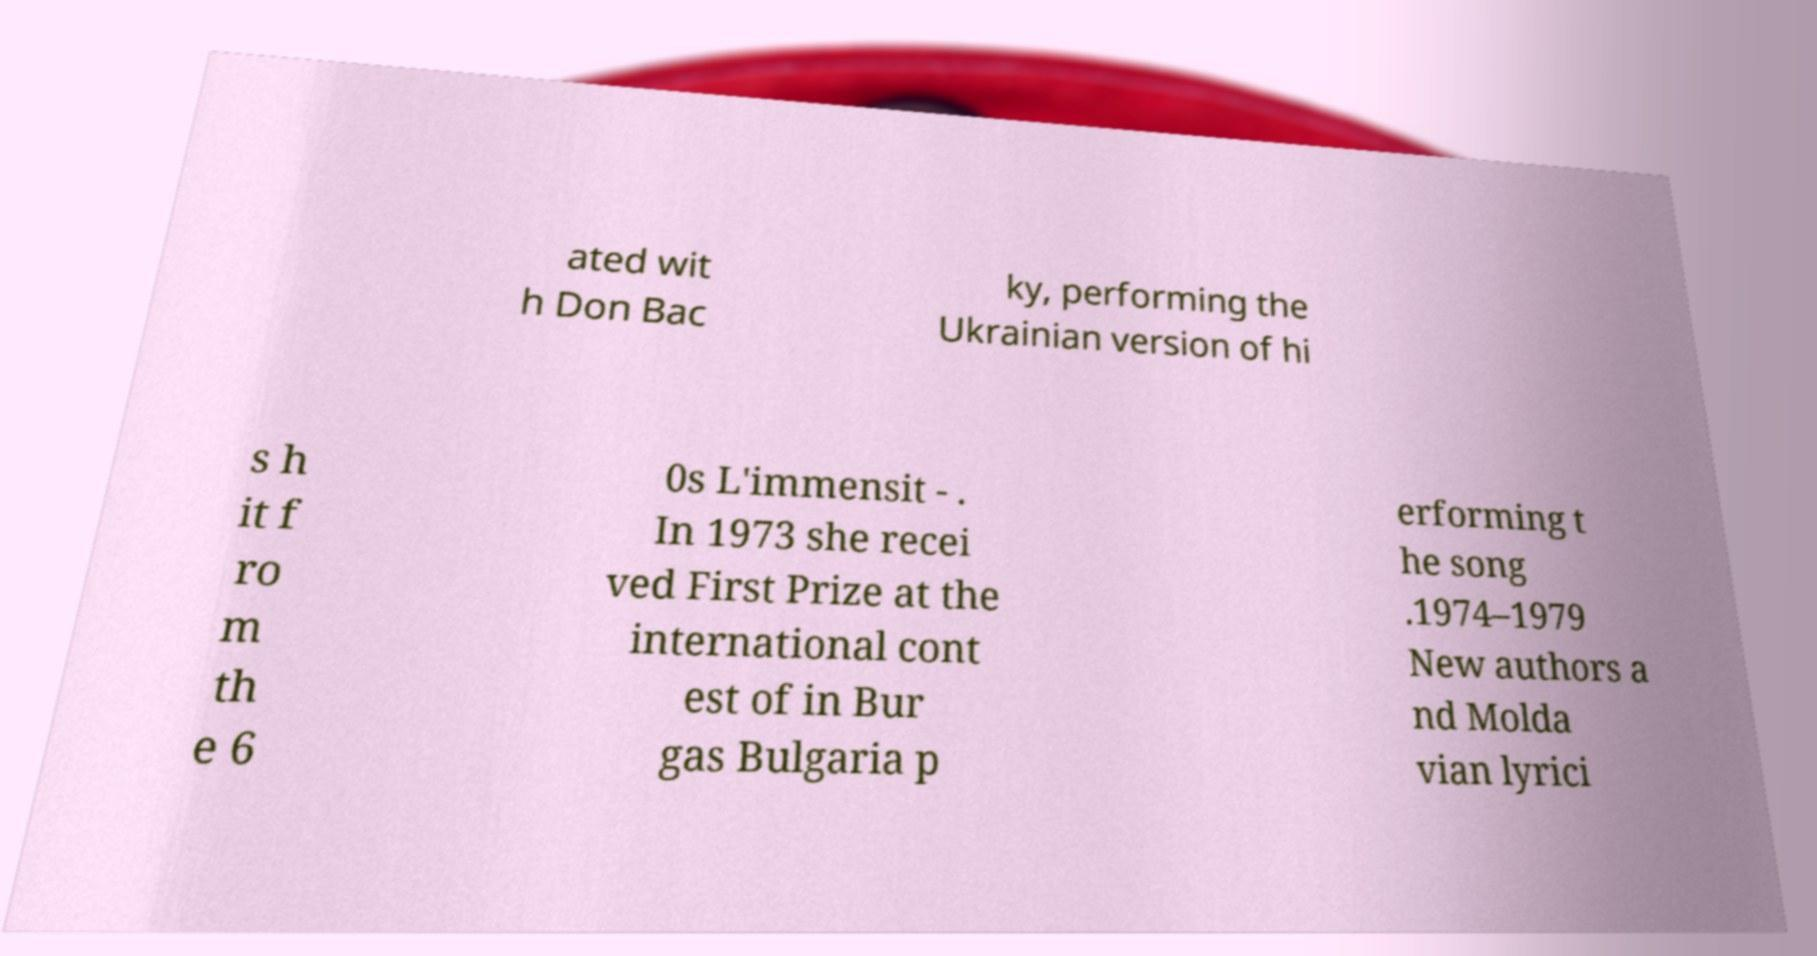Could you assist in decoding the text presented in this image and type it out clearly? ated wit h Don Bac ky, performing the Ukrainian version of hi s h it f ro m th e 6 0s L'immensit - . In 1973 she recei ved First Prize at the international cont est of in Bur gas Bulgaria p erforming t he song .1974–1979 New authors a nd Molda vian lyrici 